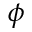Convert formula to latex. <formula><loc_0><loc_0><loc_500><loc_500>\phi</formula> 